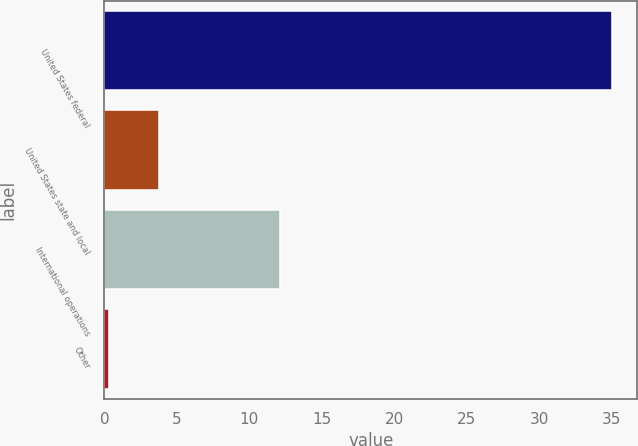<chart> <loc_0><loc_0><loc_500><loc_500><bar_chart><fcel>United States federal<fcel>United States state and local<fcel>International operations<fcel>Other<nl><fcel>35<fcel>3.77<fcel>12.1<fcel>0.3<nl></chart> 